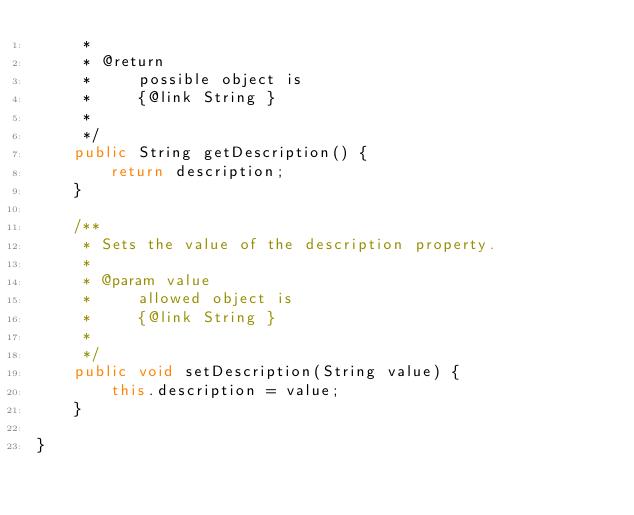<code> <loc_0><loc_0><loc_500><loc_500><_Java_>     * 
     * @return
     *     possible object is
     *     {@link String }
     *     
     */
    public String getDescription() {
        return description;
    }

    /**
     * Sets the value of the description property.
     * 
     * @param value
     *     allowed object is
     *     {@link String }
     *     
     */
    public void setDescription(String value) {
        this.description = value;
    }

}
</code> 